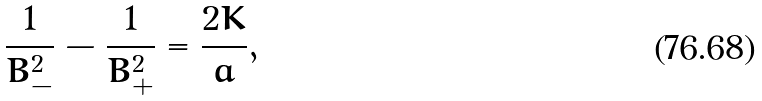<formula> <loc_0><loc_0><loc_500><loc_500>\frac { 1 } { B _ { - } ^ { 2 } } - \frac { 1 } { B _ { + } ^ { 2 } } = \frac { 2 K } { a } ,</formula> 